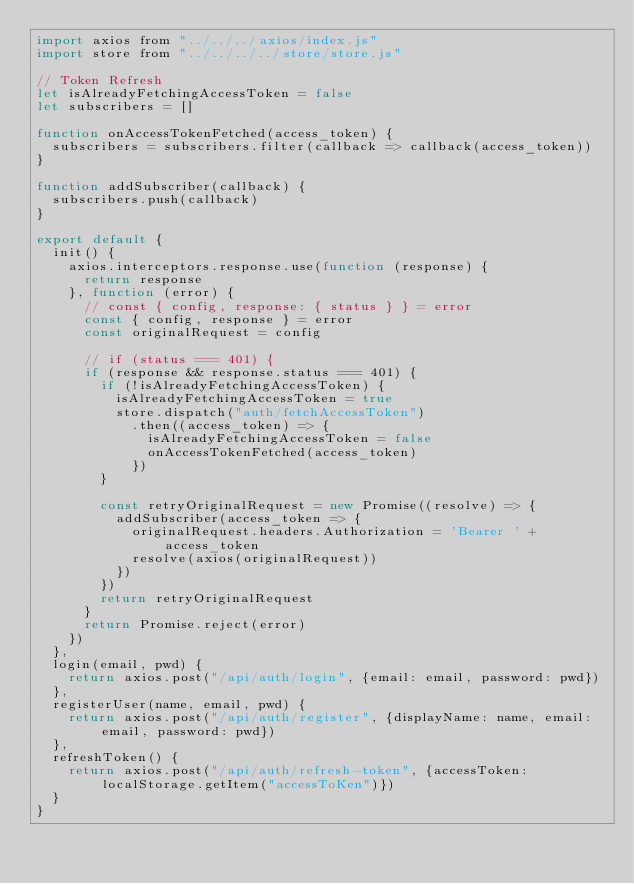<code> <loc_0><loc_0><loc_500><loc_500><_JavaScript_>import axios from "../../../axios/index.js"
import store from "../../../../store/store.js"

// Token Refresh
let isAlreadyFetchingAccessToken = false
let subscribers = []

function onAccessTokenFetched(access_token) {
  subscribers = subscribers.filter(callback => callback(access_token))
}

function addSubscriber(callback) {
  subscribers.push(callback)
}

export default {
  init() {
    axios.interceptors.response.use(function (response) {
      return response
    }, function (error) {
      // const { config, response: { status } } = error
      const { config, response } = error
      const originalRequest = config

      // if (status === 401) {
      if (response && response.status === 401) {
        if (!isAlreadyFetchingAccessToken) {
          isAlreadyFetchingAccessToken = true
          store.dispatch("auth/fetchAccessToken")
            .then((access_token) => {
              isAlreadyFetchingAccessToken = false
              onAccessTokenFetched(access_token)
            })
        }

        const retryOriginalRequest = new Promise((resolve) => {
          addSubscriber(access_token => {
            originalRequest.headers.Authorization = 'Bearer ' + access_token
            resolve(axios(originalRequest))
          })
        })
        return retryOriginalRequest
      }
      return Promise.reject(error)
    })
  },
  login(email, pwd) {
    return axios.post("/api/auth/login", {email: email, password: pwd})
  },
  registerUser(name, email, pwd) {
    return axios.post("/api/auth/register", {displayName: name, email: email, password: pwd})
  },
  refreshToken() {
    return axios.post("/api/auth/refresh-token", {accessToken: localStorage.getItem("accessToKen")})
  }
}
</code> 